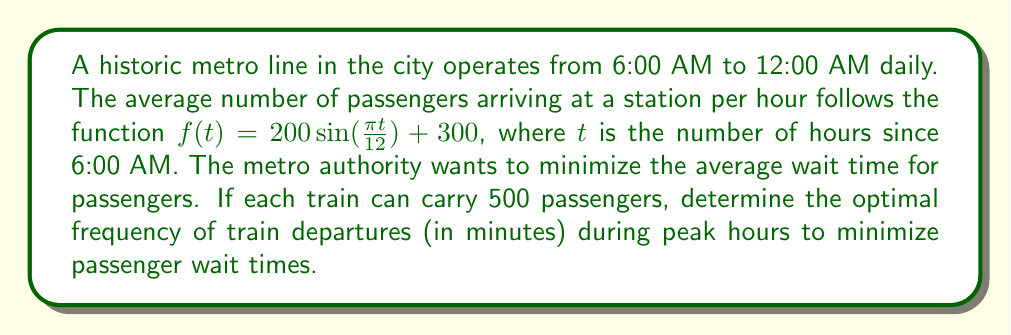Give your solution to this math problem. To solve this problem, we'll follow these steps:

1) First, we need to identify the peak hours. The passenger arrival rate is highest when $f(t)$ is at its maximum.

2) The maximum of $f(t)$ occurs when $\sin(\frac{\pi t}{12})$ = 1, which happens when $\frac{\pi t}{12} = \frac{\pi}{2}$, or $t = 6$. This corresponds to 12:00 PM.

3) At peak time, the maximum passenger arrival rate is:
   $f(6) = 200 \sin(\frac{\pi \cdot 6}{12}) + 300 = 200 \cdot 1 + 300 = 500$ passengers per hour

4) To minimize wait times, we want to match the train capacity to the arrival rate. Each train can carry 500 passengers, which matches the peak arrival rate.

5) To calculate the optimal frequency, we use the formula:
   $\text{Frequency (in hours)} = \frac{\text{Train Capacity}}{\text{Passenger Arrival Rate}}$

6) Substituting our values:
   $\text{Frequency} = \frac{500}{500} = 1$ hour

7) Convert this to minutes:
   $1 \text{ hour} = 60 \text{ minutes}$

Therefore, during peak hours, trains should depart every 60 minutes to minimize passenger wait times.
Answer: The optimal frequency of train departures during peak hours is 60 minutes. 